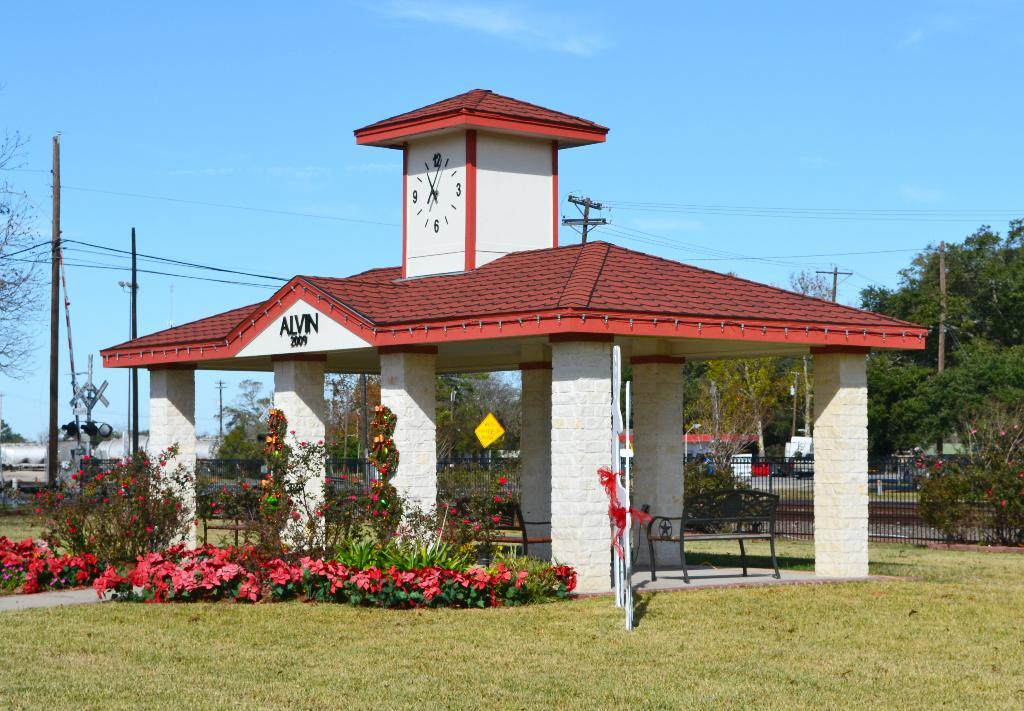What type of structures can be seen in the image? There are buildings in the image. What type of furniture is present in the image? There are chairs in the image. What type of barrier can be seen in the image? There is a fence in the image. What type of vegetation with flowers can be seen in the image? There are plants with flowers in the image. What type of tall vegetation can be seen in the image? There are trees in the image. What type of vertical structures can be seen in the image? There are electric poles in the image. What type of signage is present in the image? There is a name board in the image. What type of objects are on the ground in the image? There are objects on the ground in the image. What can be seen in the background of the image? The sky is visible in the background of the image. What type of fruit is hanging from the electric poles in the image? There is no fruit hanging from the electric poles in the image. What type of polish is being applied to the name board in the image? There is no polish being applied to the name board in the image. 